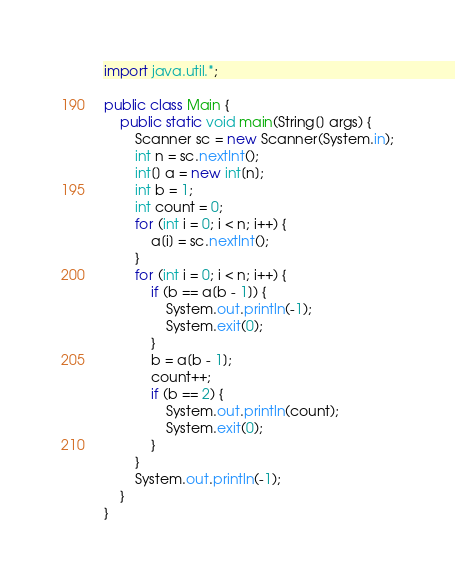Convert code to text. <code><loc_0><loc_0><loc_500><loc_500><_Java_>import java.util.*;

public class Main {
    public static void main(String[] args) {
        Scanner sc = new Scanner(System.in);
        int n = sc.nextInt();
        int[] a = new int[n];
        int b = 1;
        int count = 0;
        for (int i = 0; i < n; i++) {
            a[i] = sc.nextInt();
        }
        for (int i = 0; i < n; i++) {
            if (b == a[b - 1]) {
                System.out.println(-1);
                System.exit(0);
            }
            b = a[b - 1];
            count++;
            if (b == 2) {
                System.out.println(count);
                System.exit(0);
            }
        }
        System.out.println(-1);
    }
}
</code> 